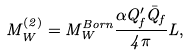Convert formula to latex. <formula><loc_0><loc_0><loc_500><loc_500>M ^ { ( 2 ) } _ { W } = M _ { W } ^ { B o r n } \frac { \alpha Q ^ { \prime } _ { f } \bar { Q } _ { f } } { 4 \pi } L ,</formula> 